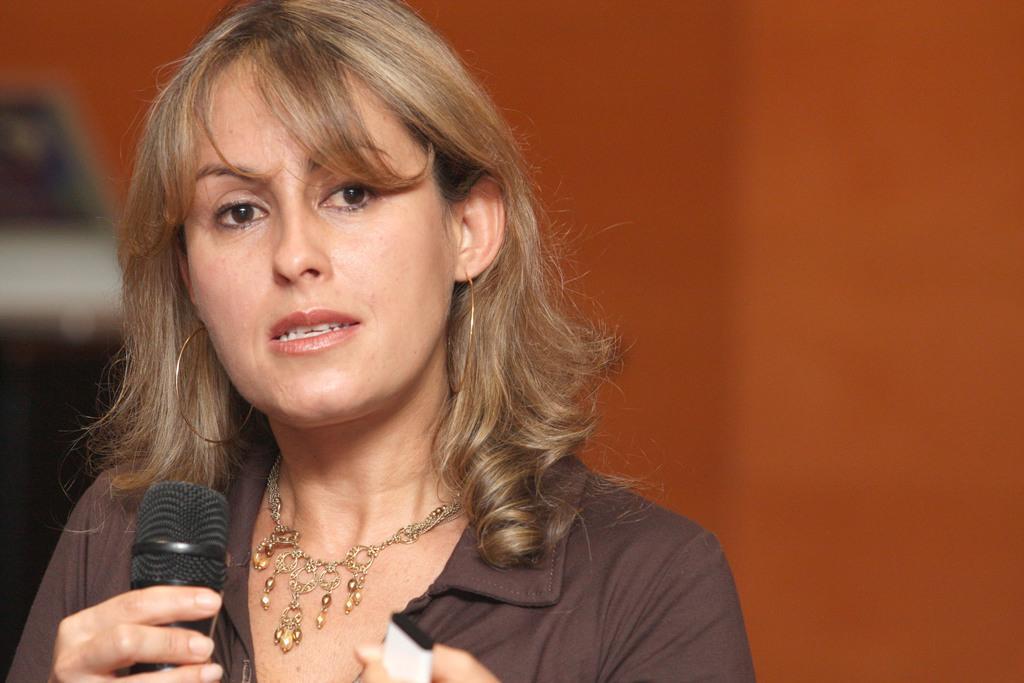How would you summarize this image in a sentence or two? In this picture there is a woman holding a mike. She is wearing a brown dress and ornament. 